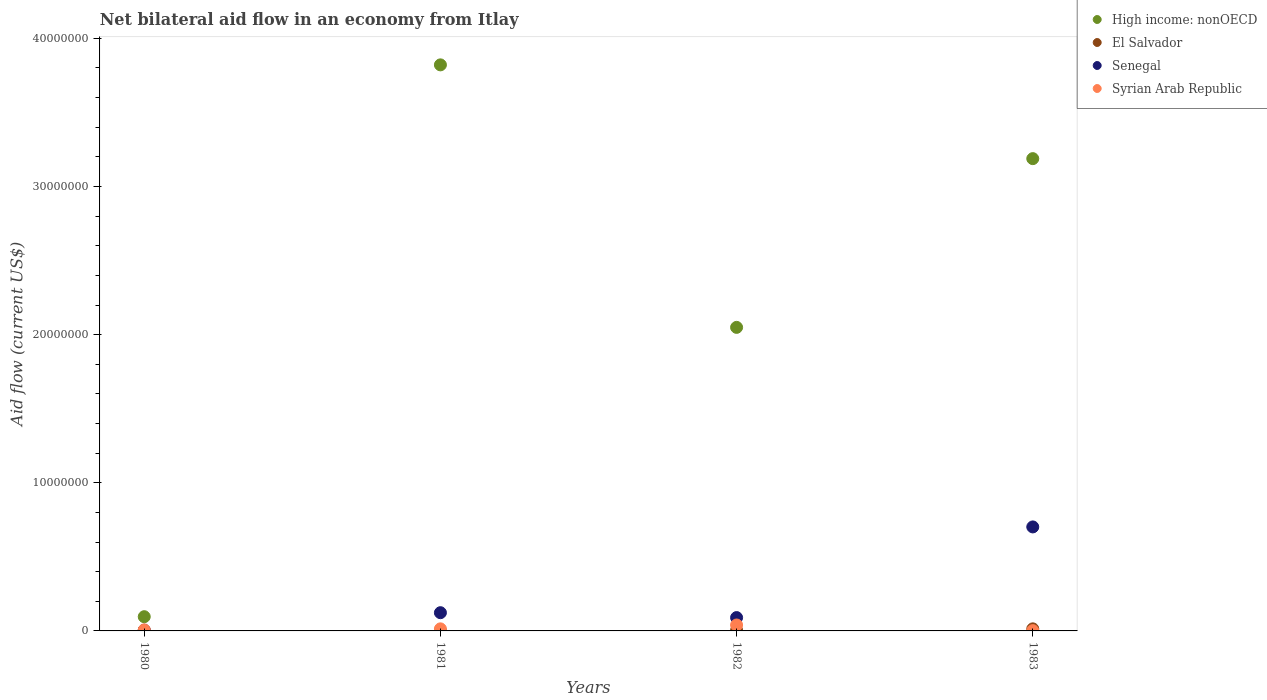What is the net bilateral aid flow in High income: nonOECD in 1981?
Give a very brief answer. 3.82e+07. Across all years, what is the maximum net bilateral aid flow in Senegal?
Your answer should be very brief. 7.02e+06. In which year was the net bilateral aid flow in El Salvador maximum?
Provide a succinct answer. 1983. What is the total net bilateral aid flow in Syrian Arab Republic in the graph?
Your answer should be compact. 6.30e+05. What is the difference between the net bilateral aid flow in High income: nonOECD in 1981 and that in 1983?
Provide a succinct answer. 6.33e+06. What is the difference between the net bilateral aid flow in El Salvador in 1983 and the net bilateral aid flow in Syrian Arab Republic in 1982?
Offer a very short reply. -2.60e+05. What is the average net bilateral aid flow in Senegal per year?
Your response must be concise. 2.30e+06. In the year 1980, what is the difference between the net bilateral aid flow in Senegal and net bilateral aid flow in El Salvador?
Your response must be concise. 2.00e+04. In how many years, is the net bilateral aid flow in High income: nonOECD greater than 4000000 US$?
Your response must be concise. 3. What is the ratio of the net bilateral aid flow in Senegal in 1982 to that in 1983?
Give a very brief answer. 0.13. Is the net bilateral aid flow in High income: nonOECD in 1981 less than that in 1983?
Provide a succinct answer. No. Is the difference between the net bilateral aid flow in Senegal in 1980 and 1983 greater than the difference between the net bilateral aid flow in El Salvador in 1980 and 1983?
Provide a short and direct response. No. What is the difference between the highest and the second highest net bilateral aid flow in Senegal?
Provide a succinct answer. 5.79e+06. What is the difference between the highest and the lowest net bilateral aid flow in High income: nonOECD?
Give a very brief answer. 3.72e+07. Is the sum of the net bilateral aid flow in El Salvador in 1982 and 1983 greater than the maximum net bilateral aid flow in High income: nonOECD across all years?
Keep it short and to the point. No. Is it the case that in every year, the sum of the net bilateral aid flow in High income: nonOECD and net bilateral aid flow in El Salvador  is greater than the net bilateral aid flow in Syrian Arab Republic?
Provide a succinct answer. Yes. Does the net bilateral aid flow in High income: nonOECD monotonically increase over the years?
Make the answer very short. No. How many dotlines are there?
Your response must be concise. 4. What is the difference between two consecutive major ticks on the Y-axis?
Your answer should be very brief. 1.00e+07. Are the values on the major ticks of Y-axis written in scientific E-notation?
Your response must be concise. No. Does the graph contain grids?
Your answer should be compact. No. How many legend labels are there?
Ensure brevity in your answer.  4. What is the title of the graph?
Provide a short and direct response. Net bilateral aid flow in an economy from Itlay. Does "Timor-Leste" appear as one of the legend labels in the graph?
Provide a short and direct response. No. What is the Aid flow (current US$) in High income: nonOECD in 1980?
Ensure brevity in your answer.  9.60e+05. What is the Aid flow (current US$) of El Salvador in 1980?
Ensure brevity in your answer.  3.00e+04. What is the Aid flow (current US$) of Syrian Arab Republic in 1980?
Provide a short and direct response. 7.00e+04. What is the Aid flow (current US$) of High income: nonOECD in 1981?
Offer a terse response. 3.82e+07. What is the Aid flow (current US$) of El Salvador in 1981?
Keep it short and to the point. 2.00e+04. What is the Aid flow (current US$) of Senegal in 1981?
Your answer should be very brief. 1.23e+06. What is the Aid flow (current US$) in Syrian Arab Republic in 1981?
Provide a succinct answer. 1.40e+05. What is the Aid flow (current US$) of High income: nonOECD in 1982?
Keep it short and to the point. 2.05e+07. What is the Aid flow (current US$) of High income: nonOECD in 1983?
Provide a short and direct response. 3.19e+07. What is the Aid flow (current US$) of El Salvador in 1983?
Ensure brevity in your answer.  1.40e+05. What is the Aid flow (current US$) in Senegal in 1983?
Provide a short and direct response. 7.02e+06. What is the Aid flow (current US$) of Syrian Arab Republic in 1983?
Provide a short and direct response. 2.00e+04. Across all years, what is the maximum Aid flow (current US$) of High income: nonOECD?
Keep it short and to the point. 3.82e+07. Across all years, what is the maximum Aid flow (current US$) in Senegal?
Give a very brief answer. 7.02e+06. Across all years, what is the maximum Aid flow (current US$) in Syrian Arab Republic?
Keep it short and to the point. 4.00e+05. Across all years, what is the minimum Aid flow (current US$) in High income: nonOECD?
Your answer should be very brief. 9.60e+05. Across all years, what is the minimum Aid flow (current US$) of El Salvador?
Offer a terse response. 2.00e+04. Across all years, what is the minimum Aid flow (current US$) of Senegal?
Your response must be concise. 5.00e+04. What is the total Aid flow (current US$) of High income: nonOECD in the graph?
Keep it short and to the point. 9.15e+07. What is the total Aid flow (current US$) in Senegal in the graph?
Provide a succinct answer. 9.20e+06. What is the total Aid flow (current US$) of Syrian Arab Republic in the graph?
Give a very brief answer. 6.30e+05. What is the difference between the Aid flow (current US$) in High income: nonOECD in 1980 and that in 1981?
Your response must be concise. -3.72e+07. What is the difference between the Aid flow (current US$) in Senegal in 1980 and that in 1981?
Provide a succinct answer. -1.18e+06. What is the difference between the Aid flow (current US$) in Syrian Arab Republic in 1980 and that in 1981?
Provide a short and direct response. -7.00e+04. What is the difference between the Aid flow (current US$) of High income: nonOECD in 1980 and that in 1982?
Make the answer very short. -1.95e+07. What is the difference between the Aid flow (current US$) in Senegal in 1980 and that in 1982?
Ensure brevity in your answer.  -8.50e+05. What is the difference between the Aid flow (current US$) in Syrian Arab Republic in 1980 and that in 1982?
Provide a short and direct response. -3.30e+05. What is the difference between the Aid flow (current US$) in High income: nonOECD in 1980 and that in 1983?
Ensure brevity in your answer.  -3.09e+07. What is the difference between the Aid flow (current US$) of Senegal in 1980 and that in 1983?
Make the answer very short. -6.97e+06. What is the difference between the Aid flow (current US$) in High income: nonOECD in 1981 and that in 1982?
Ensure brevity in your answer.  1.77e+07. What is the difference between the Aid flow (current US$) in Syrian Arab Republic in 1981 and that in 1982?
Give a very brief answer. -2.60e+05. What is the difference between the Aid flow (current US$) in High income: nonOECD in 1981 and that in 1983?
Your response must be concise. 6.33e+06. What is the difference between the Aid flow (current US$) in El Salvador in 1981 and that in 1983?
Your response must be concise. -1.20e+05. What is the difference between the Aid flow (current US$) of Senegal in 1981 and that in 1983?
Your answer should be very brief. -5.79e+06. What is the difference between the Aid flow (current US$) of High income: nonOECD in 1982 and that in 1983?
Offer a very short reply. -1.14e+07. What is the difference between the Aid flow (current US$) in Senegal in 1982 and that in 1983?
Your answer should be very brief. -6.12e+06. What is the difference between the Aid flow (current US$) in High income: nonOECD in 1980 and the Aid flow (current US$) in El Salvador in 1981?
Provide a succinct answer. 9.40e+05. What is the difference between the Aid flow (current US$) in High income: nonOECD in 1980 and the Aid flow (current US$) in Syrian Arab Republic in 1981?
Keep it short and to the point. 8.20e+05. What is the difference between the Aid flow (current US$) in El Salvador in 1980 and the Aid flow (current US$) in Senegal in 1981?
Offer a very short reply. -1.20e+06. What is the difference between the Aid flow (current US$) of High income: nonOECD in 1980 and the Aid flow (current US$) of El Salvador in 1982?
Keep it short and to the point. 9.20e+05. What is the difference between the Aid flow (current US$) of High income: nonOECD in 1980 and the Aid flow (current US$) of Syrian Arab Republic in 1982?
Ensure brevity in your answer.  5.60e+05. What is the difference between the Aid flow (current US$) in El Salvador in 1980 and the Aid flow (current US$) in Senegal in 1982?
Provide a short and direct response. -8.70e+05. What is the difference between the Aid flow (current US$) in El Salvador in 1980 and the Aid flow (current US$) in Syrian Arab Republic in 1982?
Offer a very short reply. -3.70e+05. What is the difference between the Aid flow (current US$) in Senegal in 1980 and the Aid flow (current US$) in Syrian Arab Republic in 1982?
Provide a short and direct response. -3.50e+05. What is the difference between the Aid flow (current US$) of High income: nonOECD in 1980 and the Aid flow (current US$) of El Salvador in 1983?
Your answer should be very brief. 8.20e+05. What is the difference between the Aid flow (current US$) of High income: nonOECD in 1980 and the Aid flow (current US$) of Senegal in 1983?
Offer a very short reply. -6.06e+06. What is the difference between the Aid flow (current US$) of High income: nonOECD in 1980 and the Aid flow (current US$) of Syrian Arab Republic in 1983?
Ensure brevity in your answer.  9.40e+05. What is the difference between the Aid flow (current US$) of El Salvador in 1980 and the Aid flow (current US$) of Senegal in 1983?
Make the answer very short. -6.99e+06. What is the difference between the Aid flow (current US$) of El Salvador in 1980 and the Aid flow (current US$) of Syrian Arab Republic in 1983?
Your answer should be compact. 10000. What is the difference between the Aid flow (current US$) in High income: nonOECD in 1981 and the Aid flow (current US$) in El Salvador in 1982?
Offer a terse response. 3.82e+07. What is the difference between the Aid flow (current US$) of High income: nonOECD in 1981 and the Aid flow (current US$) of Senegal in 1982?
Ensure brevity in your answer.  3.73e+07. What is the difference between the Aid flow (current US$) of High income: nonOECD in 1981 and the Aid flow (current US$) of Syrian Arab Republic in 1982?
Provide a short and direct response. 3.78e+07. What is the difference between the Aid flow (current US$) in El Salvador in 1981 and the Aid flow (current US$) in Senegal in 1982?
Ensure brevity in your answer.  -8.80e+05. What is the difference between the Aid flow (current US$) of El Salvador in 1981 and the Aid flow (current US$) of Syrian Arab Republic in 1982?
Your answer should be compact. -3.80e+05. What is the difference between the Aid flow (current US$) of Senegal in 1981 and the Aid flow (current US$) of Syrian Arab Republic in 1982?
Provide a short and direct response. 8.30e+05. What is the difference between the Aid flow (current US$) in High income: nonOECD in 1981 and the Aid flow (current US$) in El Salvador in 1983?
Make the answer very short. 3.81e+07. What is the difference between the Aid flow (current US$) in High income: nonOECD in 1981 and the Aid flow (current US$) in Senegal in 1983?
Your answer should be compact. 3.12e+07. What is the difference between the Aid flow (current US$) of High income: nonOECD in 1981 and the Aid flow (current US$) of Syrian Arab Republic in 1983?
Ensure brevity in your answer.  3.82e+07. What is the difference between the Aid flow (current US$) in El Salvador in 1981 and the Aid flow (current US$) in Senegal in 1983?
Provide a short and direct response. -7.00e+06. What is the difference between the Aid flow (current US$) of Senegal in 1981 and the Aid flow (current US$) of Syrian Arab Republic in 1983?
Offer a very short reply. 1.21e+06. What is the difference between the Aid flow (current US$) of High income: nonOECD in 1982 and the Aid flow (current US$) of El Salvador in 1983?
Provide a succinct answer. 2.04e+07. What is the difference between the Aid flow (current US$) in High income: nonOECD in 1982 and the Aid flow (current US$) in Senegal in 1983?
Your response must be concise. 1.35e+07. What is the difference between the Aid flow (current US$) of High income: nonOECD in 1982 and the Aid flow (current US$) of Syrian Arab Republic in 1983?
Make the answer very short. 2.05e+07. What is the difference between the Aid flow (current US$) in El Salvador in 1982 and the Aid flow (current US$) in Senegal in 1983?
Offer a very short reply. -6.98e+06. What is the difference between the Aid flow (current US$) of El Salvador in 1982 and the Aid flow (current US$) of Syrian Arab Republic in 1983?
Offer a very short reply. 2.00e+04. What is the difference between the Aid flow (current US$) in Senegal in 1982 and the Aid flow (current US$) in Syrian Arab Republic in 1983?
Offer a very short reply. 8.80e+05. What is the average Aid flow (current US$) of High income: nonOECD per year?
Your response must be concise. 2.29e+07. What is the average Aid flow (current US$) in El Salvador per year?
Ensure brevity in your answer.  5.75e+04. What is the average Aid flow (current US$) of Senegal per year?
Your response must be concise. 2.30e+06. What is the average Aid flow (current US$) of Syrian Arab Republic per year?
Offer a terse response. 1.58e+05. In the year 1980, what is the difference between the Aid flow (current US$) of High income: nonOECD and Aid flow (current US$) of El Salvador?
Offer a terse response. 9.30e+05. In the year 1980, what is the difference between the Aid flow (current US$) of High income: nonOECD and Aid flow (current US$) of Senegal?
Your answer should be very brief. 9.10e+05. In the year 1980, what is the difference between the Aid flow (current US$) of High income: nonOECD and Aid flow (current US$) of Syrian Arab Republic?
Your answer should be very brief. 8.90e+05. In the year 1980, what is the difference between the Aid flow (current US$) in El Salvador and Aid flow (current US$) in Syrian Arab Republic?
Your answer should be very brief. -4.00e+04. In the year 1981, what is the difference between the Aid flow (current US$) in High income: nonOECD and Aid flow (current US$) in El Salvador?
Keep it short and to the point. 3.82e+07. In the year 1981, what is the difference between the Aid flow (current US$) in High income: nonOECD and Aid flow (current US$) in Senegal?
Ensure brevity in your answer.  3.70e+07. In the year 1981, what is the difference between the Aid flow (current US$) of High income: nonOECD and Aid flow (current US$) of Syrian Arab Republic?
Make the answer very short. 3.81e+07. In the year 1981, what is the difference between the Aid flow (current US$) in El Salvador and Aid flow (current US$) in Senegal?
Give a very brief answer. -1.21e+06. In the year 1981, what is the difference between the Aid flow (current US$) in Senegal and Aid flow (current US$) in Syrian Arab Republic?
Keep it short and to the point. 1.09e+06. In the year 1982, what is the difference between the Aid flow (current US$) of High income: nonOECD and Aid flow (current US$) of El Salvador?
Offer a terse response. 2.04e+07. In the year 1982, what is the difference between the Aid flow (current US$) of High income: nonOECD and Aid flow (current US$) of Senegal?
Your answer should be compact. 1.96e+07. In the year 1982, what is the difference between the Aid flow (current US$) of High income: nonOECD and Aid flow (current US$) of Syrian Arab Republic?
Offer a terse response. 2.01e+07. In the year 1982, what is the difference between the Aid flow (current US$) of El Salvador and Aid flow (current US$) of Senegal?
Give a very brief answer. -8.60e+05. In the year 1982, what is the difference between the Aid flow (current US$) of El Salvador and Aid flow (current US$) of Syrian Arab Republic?
Offer a very short reply. -3.60e+05. In the year 1983, what is the difference between the Aid flow (current US$) in High income: nonOECD and Aid flow (current US$) in El Salvador?
Ensure brevity in your answer.  3.17e+07. In the year 1983, what is the difference between the Aid flow (current US$) of High income: nonOECD and Aid flow (current US$) of Senegal?
Ensure brevity in your answer.  2.49e+07. In the year 1983, what is the difference between the Aid flow (current US$) in High income: nonOECD and Aid flow (current US$) in Syrian Arab Republic?
Ensure brevity in your answer.  3.19e+07. In the year 1983, what is the difference between the Aid flow (current US$) in El Salvador and Aid flow (current US$) in Senegal?
Provide a short and direct response. -6.88e+06. In the year 1983, what is the difference between the Aid flow (current US$) in El Salvador and Aid flow (current US$) in Syrian Arab Republic?
Provide a succinct answer. 1.20e+05. What is the ratio of the Aid flow (current US$) in High income: nonOECD in 1980 to that in 1981?
Keep it short and to the point. 0.03. What is the ratio of the Aid flow (current US$) in Senegal in 1980 to that in 1981?
Offer a terse response. 0.04. What is the ratio of the Aid flow (current US$) in Syrian Arab Republic in 1980 to that in 1981?
Your answer should be compact. 0.5. What is the ratio of the Aid flow (current US$) of High income: nonOECD in 1980 to that in 1982?
Keep it short and to the point. 0.05. What is the ratio of the Aid flow (current US$) of El Salvador in 1980 to that in 1982?
Make the answer very short. 0.75. What is the ratio of the Aid flow (current US$) in Senegal in 1980 to that in 1982?
Ensure brevity in your answer.  0.06. What is the ratio of the Aid flow (current US$) in Syrian Arab Republic in 1980 to that in 1982?
Ensure brevity in your answer.  0.17. What is the ratio of the Aid flow (current US$) of High income: nonOECD in 1980 to that in 1983?
Your answer should be compact. 0.03. What is the ratio of the Aid flow (current US$) of El Salvador in 1980 to that in 1983?
Offer a terse response. 0.21. What is the ratio of the Aid flow (current US$) of Senegal in 1980 to that in 1983?
Give a very brief answer. 0.01. What is the ratio of the Aid flow (current US$) in Syrian Arab Republic in 1980 to that in 1983?
Offer a very short reply. 3.5. What is the ratio of the Aid flow (current US$) in High income: nonOECD in 1981 to that in 1982?
Make the answer very short. 1.86. What is the ratio of the Aid flow (current US$) in Senegal in 1981 to that in 1982?
Ensure brevity in your answer.  1.37. What is the ratio of the Aid flow (current US$) of High income: nonOECD in 1981 to that in 1983?
Offer a very short reply. 1.2. What is the ratio of the Aid flow (current US$) of El Salvador in 1981 to that in 1983?
Make the answer very short. 0.14. What is the ratio of the Aid flow (current US$) of Senegal in 1981 to that in 1983?
Keep it short and to the point. 0.18. What is the ratio of the Aid flow (current US$) of Syrian Arab Republic in 1981 to that in 1983?
Make the answer very short. 7. What is the ratio of the Aid flow (current US$) in High income: nonOECD in 1982 to that in 1983?
Keep it short and to the point. 0.64. What is the ratio of the Aid flow (current US$) in El Salvador in 1982 to that in 1983?
Your response must be concise. 0.29. What is the ratio of the Aid flow (current US$) of Senegal in 1982 to that in 1983?
Your response must be concise. 0.13. What is the difference between the highest and the second highest Aid flow (current US$) in High income: nonOECD?
Provide a succinct answer. 6.33e+06. What is the difference between the highest and the second highest Aid flow (current US$) of El Salvador?
Offer a very short reply. 1.00e+05. What is the difference between the highest and the second highest Aid flow (current US$) of Senegal?
Offer a terse response. 5.79e+06. What is the difference between the highest and the lowest Aid flow (current US$) of High income: nonOECD?
Your answer should be very brief. 3.72e+07. What is the difference between the highest and the lowest Aid flow (current US$) in Senegal?
Ensure brevity in your answer.  6.97e+06. What is the difference between the highest and the lowest Aid flow (current US$) of Syrian Arab Republic?
Keep it short and to the point. 3.80e+05. 